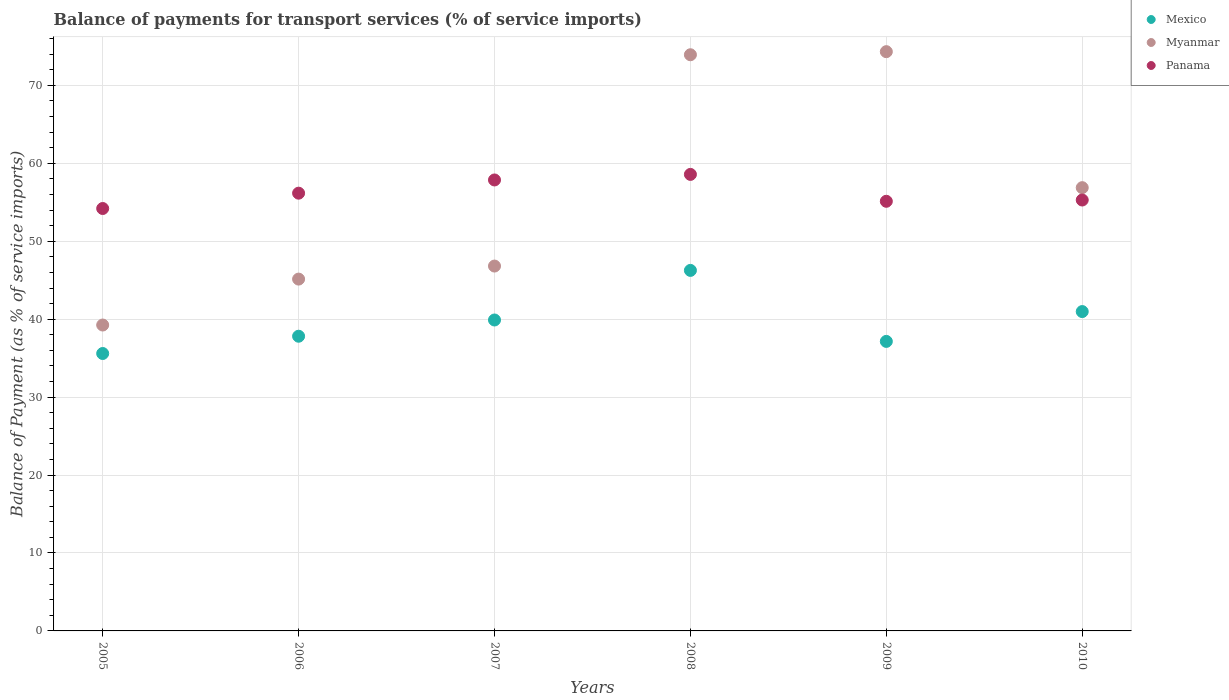How many different coloured dotlines are there?
Keep it short and to the point. 3. Is the number of dotlines equal to the number of legend labels?
Offer a terse response. Yes. What is the balance of payments for transport services in Panama in 2009?
Offer a very short reply. 55.13. Across all years, what is the maximum balance of payments for transport services in Mexico?
Your response must be concise. 46.26. Across all years, what is the minimum balance of payments for transport services in Myanmar?
Make the answer very short. 39.25. In which year was the balance of payments for transport services in Mexico minimum?
Provide a succinct answer. 2005. What is the total balance of payments for transport services in Panama in the graph?
Your answer should be compact. 337.23. What is the difference between the balance of payments for transport services in Myanmar in 2005 and that in 2006?
Make the answer very short. -5.89. What is the difference between the balance of payments for transport services in Mexico in 2007 and the balance of payments for transport services in Panama in 2009?
Your response must be concise. -15.23. What is the average balance of payments for transport services in Myanmar per year?
Offer a very short reply. 56.06. In the year 2005, what is the difference between the balance of payments for transport services in Mexico and balance of payments for transport services in Panama?
Your answer should be very brief. -18.61. In how many years, is the balance of payments for transport services in Panama greater than 44 %?
Provide a short and direct response. 6. What is the ratio of the balance of payments for transport services in Panama in 2008 to that in 2010?
Provide a succinct answer. 1.06. Is the balance of payments for transport services in Myanmar in 2009 less than that in 2010?
Your answer should be very brief. No. What is the difference between the highest and the second highest balance of payments for transport services in Myanmar?
Provide a succinct answer. 0.4. What is the difference between the highest and the lowest balance of payments for transport services in Panama?
Your answer should be very brief. 4.38. Is the sum of the balance of payments for transport services in Myanmar in 2006 and 2009 greater than the maximum balance of payments for transport services in Mexico across all years?
Ensure brevity in your answer.  Yes. Is it the case that in every year, the sum of the balance of payments for transport services in Myanmar and balance of payments for transport services in Panama  is greater than the balance of payments for transport services in Mexico?
Keep it short and to the point. Yes. Does the balance of payments for transport services in Myanmar monotonically increase over the years?
Keep it short and to the point. No. Is the balance of payments for transport services in Mexico strictly less than the balance of payments for transport services in Myanmar over the years?
Provide a short and direct response. Yes. How many dotlines are there?
Your answer should be compact. 3. How many years are there in the graph?
Provide a succinct answer. 6. Are the values on the major ticks of Y-axis written in scientific E-notation?
Offer a terse response. No. Does the graph contain any zero values?
Keep it short and to the point. No. Does the graph contain grids?
Provide a succinct answer. Yes. What is the title of the graph?
Make the answer very short. Balance of payments for transport services (% of service imports). What is the label or title of the X-axis?
Keep it short and to the point. Years. What is the label or title of the Y-axis?
Provide a succinct answer. Balance of Payment (as % of service imports). What is the Balance of Payment (as % of service imports) in Mexico in 2005?
Make the answer very short. 35.6. What is the Balance of Payment (as % of service imports) of Myanmar in 2005?
Provide a succinct answer. 39.25. What is the Balance of Payment (as % of service imports) in Panama in 2005?
Provide a short and direct response. 54.2. What is the Balance of Payment (as % of service imports) of Mexico in 2006?
Ensure brevity in your answer.  37.81. What is the Balance of Payment (as % of service imports) in Myanmar in 2006?
Offer a very short reply. 45.14. What is the Balance of Payment (as % of service imports) of Panama in 2006?
Offer a terse response. 56.17. What is the Balance of Payment (as % of service imports) in Mexico in 2007?
Give a very brief answer. 39.9. What is the Balance of Payment (as % of service imports) of Myanmar in 2007?
Provide a succinct answer. 46.82. What is the Balance of Payment (as % of service imports) of Panama in 2007?
Make the answer very short. 57.86. What is the Balance of Payment (as % of service imports) of Mexico in 2008?
Keep it short and to the point. 46.26. What is the Balance of Payment (as % of service imports) of Myanmar in 2008?
Ensure brevity in your answer.  73.93. What is the Balance of Payment (as % of service imports) of Panama in 2008?
Offer a terse response. 58.58. What is the Balance of Payment (as % of service imports) of Mexico in 2009?
Offer a terse response. 37.15. What is the Balance of Payment (as % of service imports) of Myanmar in 2009?
Provide a succinct answer. 74.33. What is the Balance of Payment (as % of service imports) in Panama in 2009?
Offer a terse response. 55.13. What is the Balance of Payment (as % of service imports) in Mexico in 2010?
Ensure brevity in your answer.  40.98. What is the Balance of Payment (as % of service imports) in Myanmar in 2010?
Offer a terse response. 56.88. What is the Balance of Payment (as % of service imports) of Panama in 2010?
Your response must be concise. 55.29. Across all years, what is the maximum Balance of Payment (as % of service imports) of Mexico?
Offer a very short reply. 46.26. Across all years, what is the maximum Balance of Payment (as % of service imports) of Myanmar?
Give a very brief answer. 74.33. Across all years, what is the maximum Balance of Payment (as % of service imports) of Panama?
Offer a terse response. 58.58. Across all years, what is the minimum Balance of Payment (as % of service imports) of Mexico?
Keep it short and to the point. 35.6. Across all years, what is the minimum Balance of Payment (as % of service imports) in Myanmar?
Your response must be concise. 39.25. Across all years, what is the minimum Balance of Payment (as % of service imports) of Panama?
Ensure brevity in your answer.  54.2. What is the total Balance of Payment (as % of service imports) in Mexico in the graph?
Keep it short and to the point. 237.69. What is the total Balance of Payment (as % of service imports) in Myanmar in the graph?
Provide a short and direct response. 336.35. What is the total Balance of Payment (as % of service imports) in Panama in the graph?
Offer a terse response. 337.23. What is the difference between the Balance of Payment (as % of service imports) of Mexico in 2005 and that in 2006?
Make the answer very short. -2.22. What is the difference between the Balance of Payment (as % of service imports) of Myanmar in 2005 and that in 2006?
Your answer should be compact. -5.89. What is the difference between the Balance of Payment (as % of service imports) in Panama in 2005 and that in 2006?
Your response must be concise. -1.97. What is the difference between the Balance of Payment (as % of service imports) of Mexico in 2005 and that in 2007?
Ensure brevity in your answer.  -4.3. What is the difference between the Balance of Payment (as % of service imports) of Myanmar in 2005 and that in 2007?
Provide a short and direct response. -7.57. What is the difference between the Balance of Payment (as % of service imports) of Panama in 2005 and that in 2007?
Offer a terse response. -3.66. What is the difference between the Balance of Payment (as % of service imports) of Mexico in 2005 and that in 2008?
Ensure brevity in your answer.  -10.66. What is the difference between the Balance of Payment (as % of service imports) in Myanmar in 2005 and that in 2008?
Your answer should be compact. -34.68. What is the difference between the Balance of Payment (as % of service imports) of Panama in 2005 and that in 2008?
Your response must be concise. -4.38. What is the difference between the Balance of Payment (as % of service imports) of Mexico in 2005 and that in 2009?
Your answer should be very brief. -1.55. What is the difference between the Balance of Payment (as % of service imports) in Myanmar in 2005 and that in 2009?
Keep it short and to the point. -35.08. What is the difference between the Balance of Payment (as % of service imports) of Panama in 2005 and that in 2009?
Your answer should be very brief. -0.93. What is the difference between the Balance of Payment (as % of service imports) in Mexico in 2005 and that in 2010?
Your answer should be very brief. -5.38. What is the difference between the Balance of Payment (as % of service imports) of Myanmar in 2005 and that in 2010?
Provide a short and direct response. -17.63. What is the difference between the Balance of Payment (as % of service imports) in Panama in 2005 and that in 2010?
Your answer should be very brief. -1.09. What is the difference between the Balance of Payment (as % of service imports) of Mexico in 2006 and that in 2007?
Ensure brevity in your answer.  -2.08. What is the difference between the Balance of Payment (as % of service imports) of Myanmar in 2006 and that in 2007?
Offer a terse response. -1.67. What is the difference between the Balance of Payment (as % of service imports) in Panama in 2006 and that in 2007?
Offer a very short reply. -1.7. What is the difference between the Balance of Payment (as % of service imports) in Mexico in 2006 and that in 2008?
Your response must be concise. -8.45. What is the difference between the Balance of Payment (as % of service imports) of Myanmar in 2006 and that in 2008?
Keep it short and to the point. -28.79. What is the difference between the Balance of Payment (as % of service imports) of Panama in 2006 and that in 2008?
Offer a very short reply. -2.41. What is the difference between the Balance of Payment (as % of service imports) of Mexico in 2006 and that in 2009?
Ensure brevity in your answer.  0.66. What is the difference between the Balance of Payment (as % of service imports) in Myanmar in 2006 and that in 2009?
Make the answer very short. -29.18. What is the difference between the Balance of Payment (as % of service imports) of Panama in 2006 and that in 2009?
Offer a terse response. 1.04. What is the difference between the Balance of Payment (as % of service imports) of Mexico in 2006 and that in 2010?
Offer a terse response. -3.16. What is the difference between the Balance of Payment (as % of service imports) of Myanmar in 2006 and that in 2010?
Ensure brevity in your answer.  -11.73. What is the difference between the Balance of Payment (as % of service imports) of Panama in 2006 and that in 2010?
Your answer should be very brief. 0.88. What is the difference between the Balance of Payment (as % of service imports) in Mexico in 2007 and that in 2008?
Provide a short and direct response. -6.36. What is the difference between the Balance of Payment (as % of service imports) in Myanmar in 2007 and that in 2008?
Your response must be concise. -27.11. What is the difference between the Balance of Payment (as % of service imports) of Panama in 2007 and that in 2008?
Your answer should be very brief. -0.71. What is the difference between the Balance of Payment (as % of service imports) of Mexico in 2007 and that in 2009?
Provide a succinct answer. 2.75. What is the difference between the Balance of Payment (as % of service imports) in Myanmar in 2007 and that in 2009?
Offer a very short reply. -27.51. What is the difference between the Balance of Payment (as % of service imports) of Panama in 2007 and that in 2009?
Keep it short and to the point. 2.74. What is the difference between the Balance of Payment (as % of service imports) in Mexico in 2007 and that in 2010?
Give a very brief answer. -1.08. What is the difference between the Balance of Payment (as % of service imports) of Myanmar in 2007 and that in 2010?
Give a very brief answer. -10.06. What is the difference between the Balance of Payment (as % of service imports) in Panama in 2007 and that in 2010?
Keep it short and to the point. 2.57. What is the difference between the Balance of Payment (as % of service imports) in Mexico in 2008 and that in 2009?
Offer a very short reply. 9.11. What is the difference between the Balance of Payment (as % of service imports) of Myanmar in 2008 and that in 2009?
Your answer should be very brief. -0.4. What is the difference between the Balance of Payment (as % of service imports) of Panama in 2008 and that in 2009?
Provide a succinct answer. 3.45. What is the difference between the Balance of Payment (as % of service imports) of Mexico in 2008 and that in 2010?
Your answer should be compact. 5.28. What is the difference between the Balance of Payment (as % of service imports) in Myanmar in 2008 and that in 2010?
Your answer should be compact. 17.05. What is the difference between the Balance of Payment (as % of service imports) in Panama in 2008 and that in 2010?
Make the answer very short. 3.29. What is the difference between the Balance of Payment (as % of service imports) of Mexico in 2009 and that in 2010?
Ensure brevity in your answer.  -3.83. What is the difference between the Balance of Payment (as % of service imports) in Myanmar in 2009 and that in 2010?
Keep it short and to the point. 17.45. What is the difference between the Balance of Payment (as % of service imports) in Panama in 2009 and that in 2010?
Give a very brief answer. -0.16. What is the difference between the Balance of Payment (as % of service imports) in Mexico in 2005 and the Balance of Payment (as % of service imports) in Myanmar in 2006?
Provide a succinct answer. -9.55. What is the difference between the Balance of Payment (as % of service imports) of Mexico in 2005 and the Balance of Payment (as % of service imports) of Panama in 2006?
Offer a terse response. -20.57. What is the difference between the Balance of Payment (as % of service imports) of Myanmar in 2005 and the Balance of Payment (as % of service imports) of Panama in 2006?
Offer a very short reply. -16.92. What is the difference between the Balance of Payment (as % of service imports) of Mexico in 2005 and the Balance of Payment (as % of service imports) of Myanmar in 2007?
Keep it short and to the point. -11.22. What is the difference between the Balance of Payment (as % of service imports) of Mexico in 2005 and the Balance of Payment (as % of service imports) of Panama in 2007?
Keep it short and to the point. -22.27. What is the difference between the Balance of Payment (as % of service imports) of Myanmar in 2005 and the Balance of Payment (as % of service imports) of Panama in 2007?
Make the answer very short. -18.61. What is the difference between the Balance of Payment (as % of service imports) in Mexico in 2005 and the Balance of Payment (as % of service imports) in Myanmar in 2008?
Keep it short and to the point. -38.33. What is the difference between the Balance of Payment (as % of service imports) of Mexico in 2005 and the Balance of Payment (as % of service imports) of Panama in 2008?
Make the answer very short. -22.98. What is the difference between the Balance of Payment (as % of service imports) of Myanmar in 2005 and the Balance of Payment (as % of service imports) of Panama in 2008?
Your response must be concise. -19.33. What is the difference between the Balance of Payment (as % of service imports) in Mexico in 2005 and the Balance of Payment (as % of service imports) in Myanmar in 2009?
Provide a short and direct response. -38.73. What is the difference between the Balance of Payment (as % of service imports) of Mexico in 2005 and the Balance of Payment (as % of service imports) of Panama in 2009?
Provide a succinct answer. -19.53. What is the difference between the Balance of Payment (as % of service imports) in Myanmar in 2005 and the Balance of Payment (as % of service imports) in Panama in 2009?
Your response must be concise. -15.88. What is the difference between the Balance of Payment (as % of service imports) in Mexico in 2005 and the Balance of Payment (as % of service imports) in Myanmar in 2010?
Keep it short and to the point. -21.28. What is the difference between the Balance of Payment (as % of service imports) in Mexico in 2005 and the Balance of Payment (as % of service imports) in Panama in 2010?
Ensure brevity in your answer.  -19.69. What is the difference between the Balance of Payment (as % of service imports) of Myanmar in 2005 and the Balance of Payment (as % of service imports) of Panama in 2010?
Keep it short and to the point. -16.04. What is the difference between the Balance of Payment (as % of service imports) of Mexico in 2006 and the Balance of Payment (as % of service imports) of Myanmar in 2007?
Offer a terse response. -9. What is the difference between the Balance of Payment (as % of service imports) in Mexico in 2006 and the Balance of Payment (as % of service imports) in Panama in 2007?
Give a very brief answer. -20.05. What is the difference between the Balance of Payment (as % of service imports) in Myanmar in 2006 and the Balance of Payment (as % of service imports) in Panama in 2007?
Provide a succinct answer. -12.72. What is the difference between the Balance of Payment (as % of service imports) in Mexico in 2006 and the Balance of Payment (as % of service imports) in Myanmar in 2008?
Your answer should be very brief. -36.12. What is the difference between the Balance of Payment (as % of service imports) in Mexico in 2006 and the Balance of Payment (as % of service imports) in Panama in 2008?
Provide a succinct answer. -20.77. What is the difference between the Balance of Payment (as % of service imports) of Myanmar in 2006 and the Balance of Payment (as % of service imports) of Panama in 2008?
Offer a terse response. -13.43. What is the difference between the Balance of Payment (as % of service imports) of Mexico in 2006 and the Balance of Payment (as % of service imports) of Myanmar in 2009?
Provide a short and direct response. -36.51. What is the difference between the Balance of Payment (as % of service imports) in Mexico in 2006 and the Balance of Payment (as % of service imports) in Panama in 2009?
Offer a very short reply. -17.31. What is the difference between the Balance of Payment (as % of service imports) of Myanmar in 2006 and the Balance of Payment (as % of service imports) of Panama in 2009?
Your response must be concise. -9.98. What is the difference between the Balance of Payment (as % of service imports) in Mexico in 2006 and the Balance of Payment (as % of service imports) in Myanmar in 2010?
Give a very brief answer. -19.06. What is the difference between the Balance of Payment (as % of service imports) in Mexico in 2006 and the Balance of Payment (as % of service imports) in Panama in 2010?
Provide a short and direct response. -17.48. What is the difference between the Balance of Payment (as % of service imports) of Myanmar in 2006 and the Balance of Payment (as % of service imports) of Panama in 2010?
Your response must be concise. -10.15. What is the difference between the Balance of Payment (as % of service imports) of Mexico in 2007 and the Balance of Payment (as % of service imports) of Myanmar in 2008?
Your response must be concise. -34.03. What is the difference between the Balance of Payment (as % of service imports) of Mexico in 2007 and the Balance of Payment (as % of service imports) of Panama in 2008?
Offer a very short reply. -18.68. What is the difference between the Balance of Payment (as % of service imports) of Myanmar in 2007 and the Balance of Payment (as % of service imports) of Panama in 2008?
Offer a terse response. -11.76. What is the difference between the Balance of Payment (as % of service imports) in Mexico in 2007 and the Balance of Payment (as % of service imports) in Myanmar in 2009?
Your answer should be compact. -34.43. What is the difference between the Balance of Payment (as % of service imports) in Mexico in 2007 and the Balance of Payment (as % of service imports) in Panama in 2009?
Your answer should be compact. -15.23. What is the difference between the Balance of Payment (as % of service imports) of Myanmar in 2007 and the Balance of Payment (as % of service imports) of Panama in 2009?
Your answer should be compact. -8.31. What is the difference between the Balance of Payment (as % of service imports) of Mexico in 2007 and the Balance of Payment (as % of service imports) of Myanmar in 2010?
Make the answer very short. -16.98. What is the difference between the Balance of Payment (as % of service imports) in Mexico in 2007 and the Balance of Payment (as % of service imports) in Panama in 2010?
Give a very brief answer. -15.39. What is the difference between the Balance of Payment (as % of service imports) in Myanmar in 2007 and the Balance of Payment (as % of service imports) in Panama in 2010?
Make the answer very short. -8.47. What is the difference between the Balance of Payment (as % of service imports) of Mexico in 2008 and the Balance of Payment (as % of service imports) of Myanmar in 2009?
Your answer should be very brief. -28.07. What is the difference between the Balance of Payment (as % of service imports) in Mexico in 2008 and the Balance of Payment (as % of service imports) in Panama in 2009?
Provide a short and direct response. -8.87. What is the difference between the Balance of Payment (as % of service imports) of Myanmar in 2008 and the Balance of Payment (as % of service imports) of Panama in 2009?
Give a very brief answer. 18.8. What is the difference between the Balance of Payment (as % of service imports) of Mexico in 2008 and the Balance of Payment (as % of service imports) of Myanmar in 2010?
Keep it short and to the point. -10.62. What is the difference between the Balance of Payment (as % of service imports) of Mexico in 2008 and the Balance of Payment (as % of service imports) of Panama in 2010?
Your response must be concise. -9.03. What is the difference between the Balance of Payment (as % of service imports) of Myanmar in 2008 and the Balance of Payment (as % of service imports) of Panama in 2010?
Keep it short and to the point. 18.64. What is the difference between the Balance of Payment (as % of service imports) of Mexico in 2009 and the Balance of Payment (as % of service imports) of Myanmar in 2010?
Offer a very short reply. -19.73. What is the difference between the Balance of Payment (as % of service imports) of Mexico in 2009 and the Balance of Payment (as % of service imports) of Panama in 2010?
Provide a short and direct response. -18.14. What is the difference between the Balance of Payment (as % of service imports) of Myanmar in 2009 and the Balance of Payment (as % of service imports) of Panama in 2010?
Your response must be concise. 19.04. What is the average Balance of Payment (as % of service imports) in Mexico per year?
Give a very brief answer. 39.62. What is the average Balance of Payment (as % of service imports) in Myanmar per year?
Ensure brevity in your answer.  56.06. What is the average Balance of Payment (as % of service imports) of Panama per year?
Provide a short and direct response. 56.21. In the year 2005, what is the difference between the Balance of Payment (as % of service imports) in Mexico and Balance of Payment (as % of service imports) in Myanmar?
Provide a short and direct response. -3.65. In the year 2005, what is the difference between the Balance of Payment (as % of service imports) in Mexico and Balance of Payment (as % of service imports) in Panama?
Your answer should be very brief. -18.61. In the year 2005, what is the difference between the Balance of Payment (as % of service imports) in Myanmar and Balance of Payment (as % of service imports) in Panama?
Give a very brief answer. -14.95. In the year 2006, what is the difference between the Balance of Payment (as % of service imports) in Mexico and Balance of Payment (as % of service imports) in Myanmar?
Provide a succinct answer. -7.33. In the year 2006, what is the difference between the Balance of Payment (as % of service imports) in Mexico and Balance of Payment (as % of service imports) in Panama?
Your response must be concise. -18.36. In the year 2006, what is the difference between the Balance of Payment (as % of service imports) of Myanmar and Balance of Payment (as % of service imports) of Panama?
Provide a succinct answer. -11.03. In the year 2007, what is the difference between the Balance of Payment (as % of service imports) in Mexico and Balance of Payment (as % of service imports) in Myanmar?
Your response must be concise. -6.92. In the year 2007, what is the difference between the Balance of Payment (as % of service imports) of Mexico and Balance of Payment (as % of service imports) of Panama?
Offer a terse response. -17.97. In the year 2007, what is the difference between the Balance of Payment (as % of service imports) of Myanmar and Balance of Payment (as % of service imports) of Panama?
Give a very brief answer. -11.05. In the year 2008, what is the difference between the Balance of Payment (as % of service imports) of Mexico and Balance of Payment (as % of service imports) of Myanmar?
Your answer should be compact. -27.67. In the year 2008, what is the difference between the Balance of Payment (as % of service imports) of Mexico and Balance of Payment (as % of service imports) of Panama?
Give a very brief answer. -12.32. In the year 2008, what is the difference between the Balance of Payment (as % of service imports) of Myanmar and Balance of Payment (as % of service imports) of Panama?
Your response must be concise. 15.35. In the year 2009, what is the difference between the Balance of Payment (as % of service imports) in Mexico and Balance of Payment (as % of service imports) in Myanmar?
Your answer should be compact. -37.18. In the year 2009, what is the difference between the Balance of Payment (as % of service imports) of Mexico and Balance of Payment (as % of service imports) of Panama?
Offer a very short reply. -17.98. In the year 2009, what is the difference between the Balance of Payment (as % of service imports) in Myanmar and Balance of Payment (as % of service imports) in Panama?
Offer a terse response. 19.2. In the year 2010, what is the difference between the Balance of Payment (as % of service imports) in Mexico and Balance of Payment (as % of service imports) in Myanmar?
Offer a terse response. -15.9. In the year 2010, what is the difference between the Balance of Payment (as % of service imports) of Mexico and Balance of Payment (as % of service imports) of Panama?
Provide a short and direct response. -14.31. In the year 2010, what is the difference between the Balance of Payment (as % of service imports) in Myanmar and Balance of Payment (as % of service imports) in Panama?
Give a very brief answer. 1.59. What is the ratio of the Balance of Payment (as % of service imports) in Mexico in 2005 to that in 2006?
Ensure brevity in your answer.  0.94. What is the ratio of the Balance of Payment (as % of service imports) in Myanmar in 2005 to that in 2006?
Give a very brief answer. 0.87. What is the ratio of the Balance of Payment (as % of service imports) of Mexico in 2005 to that in 2007?
Give a very brief answer. 0.89. What is the ratio of the Balance of Payment (as % of service imports) of Myanmar in 2005 to that in 2007?
Provide a succinct answer. 0.84. What is the ratio of the Balance of Payment (as % of service imports) of Panama in 2005 to that in 2007?
Provide a succinct answer. 0.94. What is the ratio of the Balance of Payment (as % of service imports) in Mexico in 2005 to that in 2008?
Your response must be concise. 0.77. What is the ratio of the Balance of Payment (as % of service imports) of Myanmar in 2005 to that in 2008?
Offer a terse response. 0.53. What is the ratio of the Balance of Payment (as % of service imports) in Panama in 2005 to that in 2008?
Provide a short and direct response. 0.93. What is the ratio of the Balance of Payment (as % of service imports) in Mexico in 2005 to that in 2009?
Your answer should be compact. 0.96. What is the ratio of the Balance of Payment (as % of service imports) of Myanmar in 2005 to that in 2009?
Make the answer very short. 0.53. What is the ratio of the Balance of Payment (as % of service imports) of Panama in 2005 to that in 2009?
Provide a short and direct response. 0.98. What is the ratio of the Balance of Payment (as % of service imports) of Mexico in 2005 to that in 2010?
Ensure brevity in your answer.  0.87. What is the ratio of the Balance of Payment (as % of service imports) of Myanmar in 2005 to that in 2010?
Your answer should be compact. 0.69. What is the ratio of the Balance of Payment (as % of service imports) in Panama in 2005 to that in 2010?
Keep it short and to the point. 0.98. What is the ratio of the Balance of Payment (as % of service imports) of Mexico in 2006 to that in 2007?
Provide a short and direct response. 0.95. What is the ratio of the Balance of Payment (as % of service imports) in Myanmar in 2006 to that in 2007?
Provide a short and direct response. 0.96. What is the ratio of the Balance of Payment (as % of service imports) in Panama in 2006 to that in 2007?
Provide a short and direct response. 0.97. What is the ratio of the Balance of Payment (as % of service imports) in Mexico in 2006 to that in 2008?
Your response must be concise. 0.82. What is the ratio of the Balance of Payment (as % of service imports) in Myanmar in 2006 to that in 2008?
Your response must be concise. 0.61. What is the ratio of the Balance of Payment (as % of service imports) of Panama in 2006 to that in 2008?
Make the answer very short. 0.96. What is the ratio of the Balance of Payment (as % of service imports) in Mexico in 2006 to that in 2009?
Your answer should be compact. 1.02. What is the ratio of the Balance of Payment (as % of service imports) of Myanmar in 2006 to that in 2009?
Offer a very short reply. 0.61. What is the ratio of the Balance of Payment (as % of service imports) in Panama in 2006 to that in 2009?
Ensure brevity in your answer.  1.02. What is the ratio of the Balance of Payment (as % of service imports) of Mexico in 2006 to that in 2010?
Make the answer very short. 0.92. What is the ratio of the Balance of Payment (as % of service imports) of Myanmar in 2006 to that in 2010?
Provide a short and direct response. 0.79. What is the ratio of the Balance of Payment (as % of service imports) of Panama in 2006 to that in 2010?
Ensure brevity in your answer.  1.02. What is the ratio of the Balance of Payment (as % of service imports) in Mexico in 2007 to that in 2008?
Provide a succinct answer. 0.86. What is the ratio of the Balance of Payment (as % of service imports) of Myanmar in 2007 to that in 2008?
Ensure brevity in your answer.  0.63. What is the ratio of the Balance of Payment (as % of service imports) in Panama in 2007 to that in 2008?
Make the answer very short. 0.99. What is the ratio of the Balance of Payment (as % of service imports) in Mexico in 2007 to that in 2009?
Provide a succinct answer. 1.07. What is the ratio of the Balance of Payment (as % of service imports) in Myanmar in 2007 to that in 2009?
Make the answer very short. 0.63. What is the ratio of the Balance of Payment (as % of service imports) in Panama in 2007 to that in 2009?
Offer a terse response. 1.05. What is the ratio of the Balance of Payment (as % of service imports) of Mexico in 2007 to that in 2010?
Give a very brief answer. 0.97. What is the ratio of the Balance of Payment (as % of service imports) of Myanmar in 2007 to that in 2010?
Your answer should be very brief. 0.82. What is the ratio of the Balance of Payment (as % of service imports) in Panama in 2007 to that in 2010?
Offer a terse response. 1.05. What is the ratio of the Balance of Payment (as % of service imports) of Mexico in 2008 to that in 2009?
Your answer should be compact. 1.25. What is the ratio of the Balance of Payment (as % of service imports) of Panama in 2008 to that in 2009?
Provide a short and direct response. 1.06. What is the ratio of the Balance of Payment (as % of service imports) of Mexico in 2008 to that in 2010?
Give a very brief answer. 1.13. What is the ratio of the Balance of Payment (as % of service imports) of Myanmar in 2008 to that in 2010?
Make the answer very short. 1.3. What is the ratio of the Balance of Payment (as % of service imports) of Panama in 2008 to that in 2010?
Your answer should be compact. 1.06. What is the ratio of the Balance of Payment (as % of service imports) in Mexico in 2009 to that in 2010?
Keep it short and to the point. 0.91. What is the ratio of the Balance of Payment (as % of service imports) of Myanmar in 2009 to that in 2010?
Make the answer very short. 1.31. What is the difference between the highest and the second highest Balance of Payment (as % of service imports) of Mexico?
Your answer should be very brief. 5.28. What is the difference between the highest and the second highest Balance of Payment (as % of service imports) in Myanmar?
Provide a succinct answer. 0.4. What is the difference between the highest and the second highest Balance of Payment (as % of service imports) of Panama?
Keep it short and to the point. 0.71. What is the difference between the highest and the lowest Balance of Payment (as % of service imports) of Mexico?
Provide a succinct answer. 10.66. What is the difference between the highest and the lowest Balance of Payment (as % of service imports) of Myanmar?
Your response must be concise. 35.08. What is the difference between the highest and the lowest Balance of Payment (as % of service imports) of Panama?
Your answer should be very brief. 4.38. 